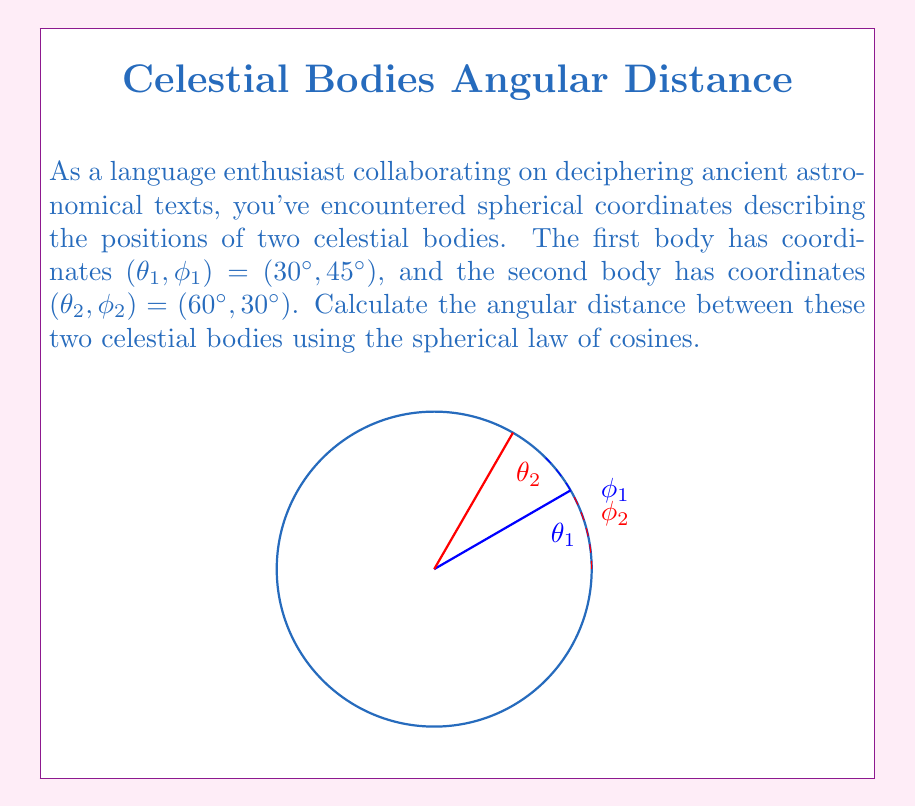Could you help me with this problem? To calculate the angular distance between two celestial bodies using spherical coordinates, we'll use the spherical law of cosines:

$$\cos(c) = \sin(\theta_1)\sin(\theta_2) + \cos(\theta_1)\cos(\theta_2)\cos(\phi_1 - \phi_2)$$

Where:
- $c$ is the angular distance we're looking for
- $(\theta_1, \phi_1)$ are the coordinates of the first body
- $(\theta_2, \phi_2)$ are the coordinates of the second body

Let's solve this step by step:

1) First, convert all angles to radians:
   $\theta_1 = 30° = \frac{\pi}{6}$ rad
   $\phi_1 = 45° = \frac{\pi}{4}$ rad
   $\theta_2 = 60° = \frac{\pi}{3}$ rad
   $\phi_2 = 30° = \frac{\pi}{6}$ rad

2) Now, let's substitute these values into the formula:

   $$\cos(c) = \sin(\frac{\pi}{6})\sin(\frac{\pi}{3}) + \cos(\frac{\pi}{6})\cos(\frac{\pi}{3})\cos(\frac{\pi}{4} - \frac{\pi}{6})$$

3) Calculate the difference $\phi_1 - \phi_2$:
   $\frac{\pi}{4} - \frac{\pi}{6} = \frac{\pi}{12}$

4) Now compute each part:
   $\sin(\frac{\pi}{6}) = 0.5$
   $\sin(\frac{\pi}{3}) = \frac{\sqrt{3}}{2}$
   $\cos(\frac{\pi}{6}) = \frac{\sqrt{3}}{2}$
   $\cos(\frac{\pi}{3}) = 0.5$
   $\cos(\frac{\pi}{12}) = \frac{\sqrt{6}+\sqrt{2}}{4}$

5) Substitute these values:

   $$\cos(c) = (0.5)(\frac{\sqrt{3}}{2}) + (\frac{\sqrt{3}}{2})(0.5)(\frac{\sqrt{6}+\sqrt{2}}{4})$$

6) Simplify:

   $$\cos(c) = \frac{\sqrt{3}}{4} + \frac{\sqrt{3}(\sqrt{6}+\sqrt{2})}{16}$$

7) To find $c$, we need to take the inverse cosine (arccos) of both sides:

   $$c = \arccos(\frac{\sqrt{3}}{4} + \frac{\sqrt{3}(\sqrt{6}+\sqrt{2})}{16})$$

8) Using a calculator, we get:

   $c \approx 0.5227$ radians

9) Convert back to degrees:

   $c \approx 0.5227 \times \frac{180°}{\pi} \approx 29.96°$
Answer: $29.96°$ 